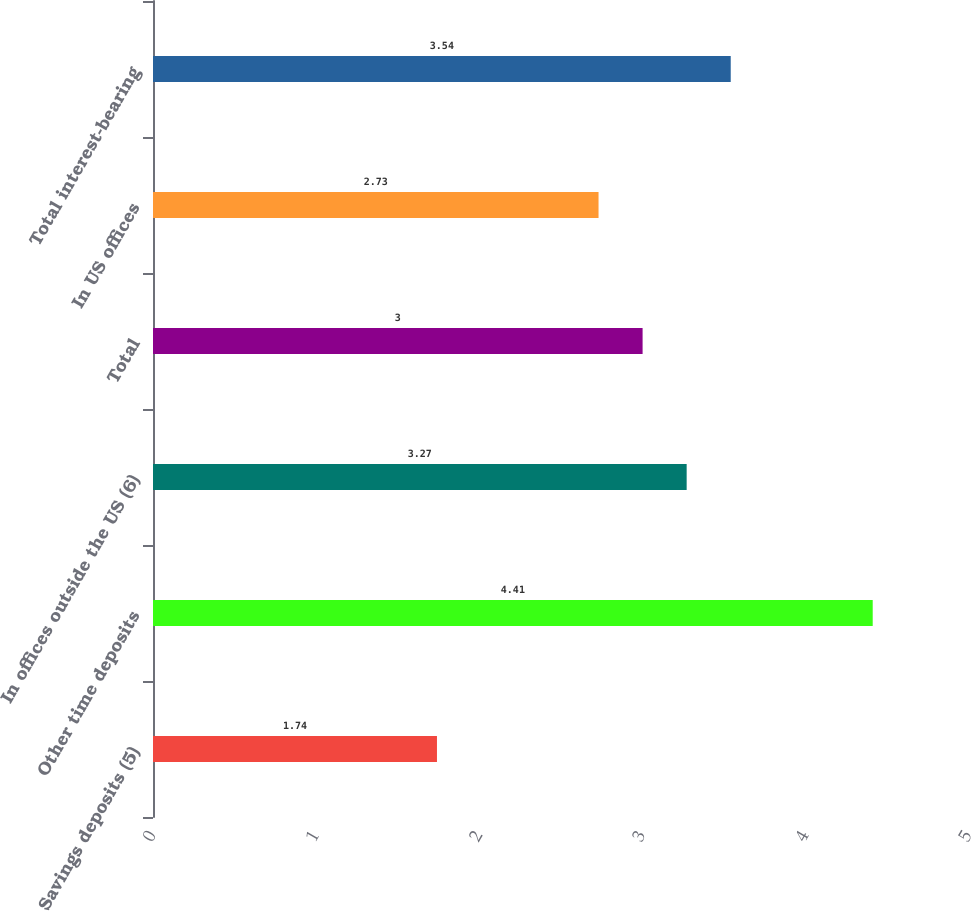<chart> <loc_0><loc_0><loc_500><loc_500><bar_chart><fcel>Savings deposits (5)<fcel>Other time deposits<fcel>In offices outside the US (6)<fcel>Total<fcel>In US offices<fcel>Total interest-bearing<nl><fcel>1.74<fcel>4.41<fcel>3.27<fcel>3<fcel>2.73<fcel>3.54<nl></chart> 